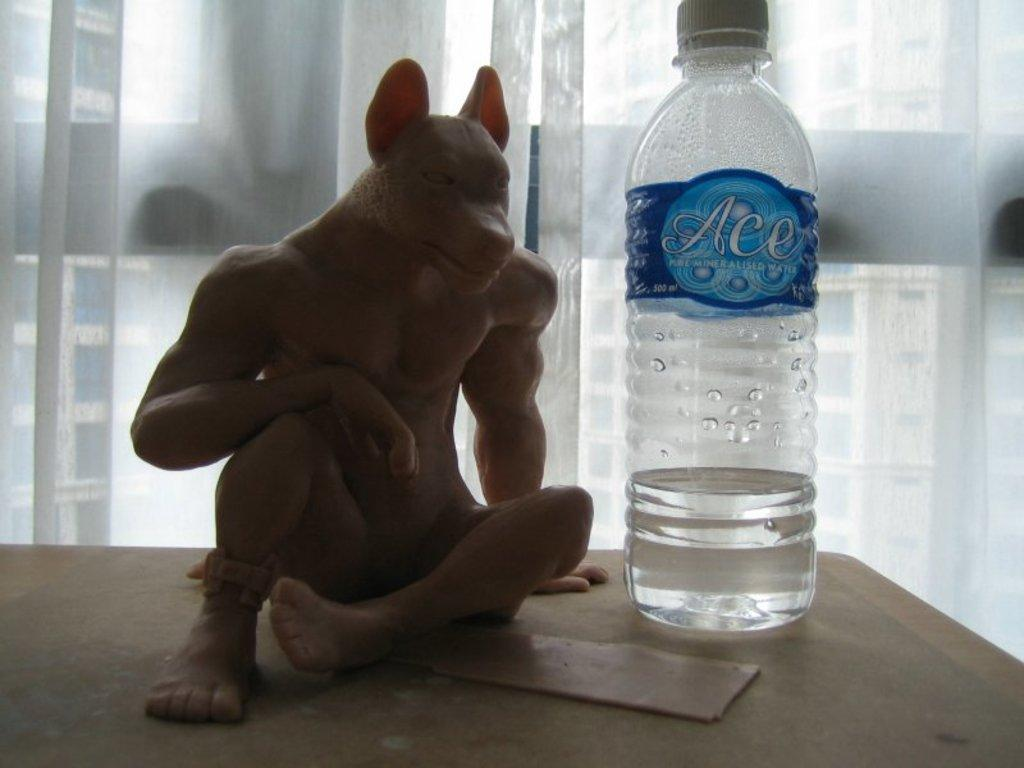What type of furniture is present in the image? There is a table in the image. What color is the table? The table is yellow. What objects can be seen on the table? There is a bottle and a brown toy on the table. What color object can be seen in the background of the image? There is a white color glass in the background of the image. Can you tell me how many parents are sitting on the chair in the image? There is no chair or parent present in the image. What type of produce is visible on the table in the image? There is no produce visible on the table in the image. 